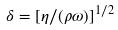<formula> <loc_0><loc_0><loc_500><loc_500>\delta = [ \eta / ( \rho \omega ) ] ^ { 1 / 2 }</formula> 